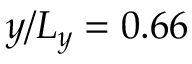<formula> <loc_0><loc_0><loc_500><loc_500>y / L _ { y } = 0 . 6 6</formula> 